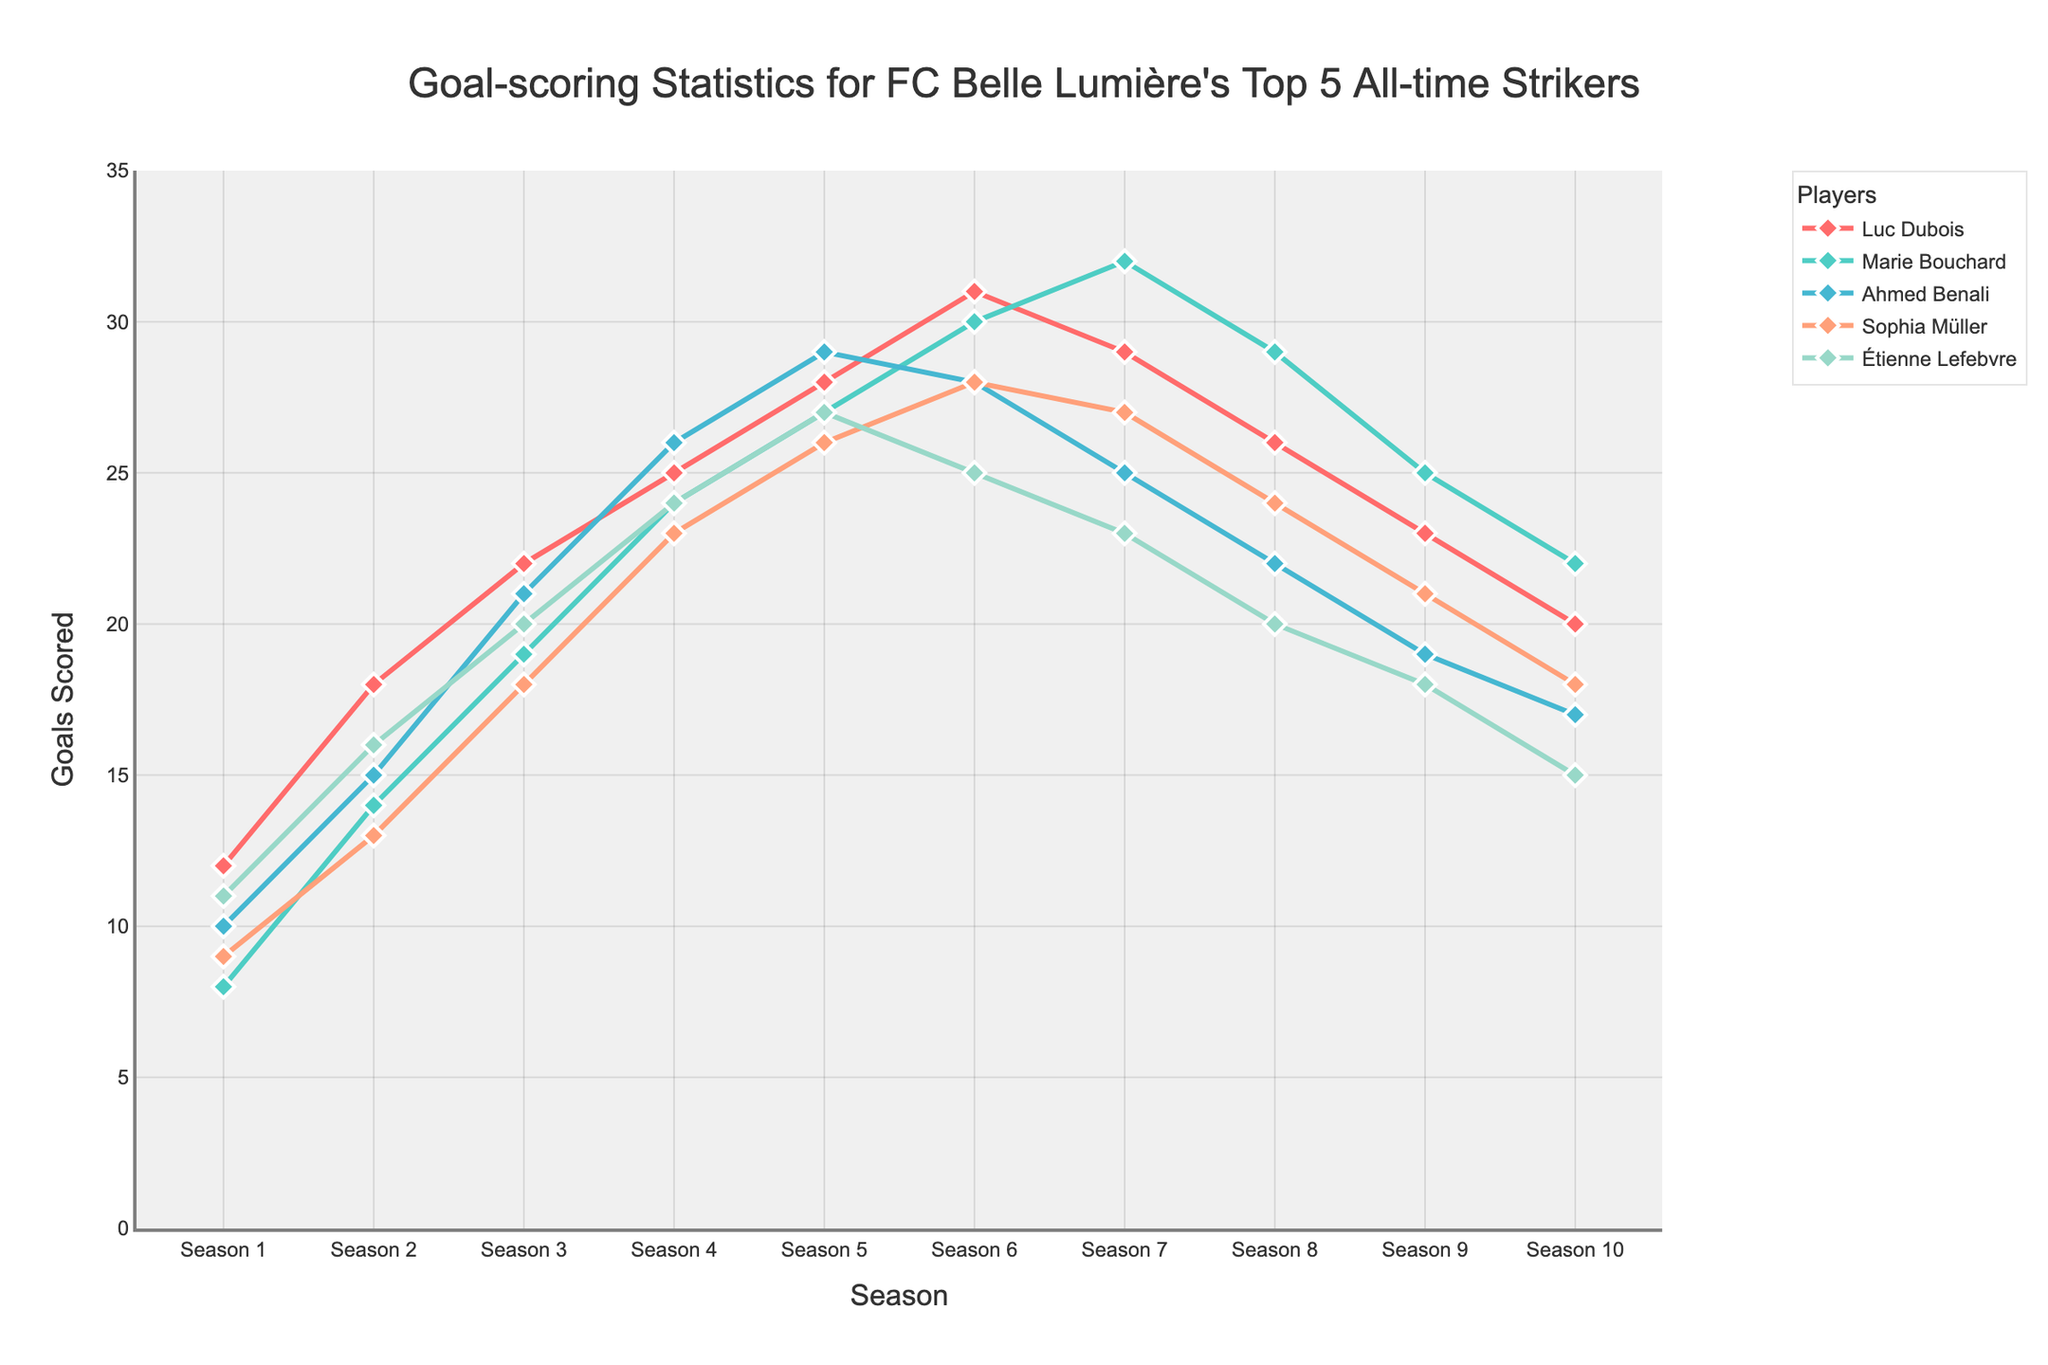What's the total number of goals scored by Luc Dubois after Season 5? After Season 5, Luc Dubois scored: 28 (Season 5) + 31 (Season 6) + 29 (Season 7) + 26 (Season 8) + 23 (Season 9) + 20 (Season 10) = 157 goals.
Answer: 157 Which player had the highest number of goals in their career's peak season? Marie Bouchard scored the highest with 32 goals in Season 7.
Answer: Marie Bouchard Between Ahmed Benali and Sophia Müller, who had a higher goal count in Season 4? In Season 4, Ahmed Benali scored 26 goals, while Sophia Müller scored 23 goals.
Answer: Ahmed Benali Which player showed a decline in goals scored over the last 3 seasons? Examining the last 3 seasons: Luc Dubois (26, 23, 20), Ahmed Benali (22, 19, 17), Sophia Müller (24, 21, 18), Étienne Lefebvre (20, 18, 15), all show a decline, but Marie Bouchard shows the smallest decline (29, 25, 22).
Answer: Ahmed Benali, Luc Dubois, Sophia Müller, Étienne Lefebvre What's the average number of goals scored by Sophia Müller over her first 5 seasons? Over her first 5 seasons, Sophia Müller scored: (9 + 13 + 18 + 23 + 26) = 89 goals. The average is 89/5 = 17.8.
Answer: 17.8 How many goals did Étienne Lefebvre score in total over his career? Summing up goals for all seasons: 11 + 16 + 20 + 24 + 27 + 25 + 23 + 20 + 18 + 15 = 199 goals.
Answer: 199 Who had the steepest increase in goals from Season 1 to their peak season? Marie Bouchard increased from 8 to 32 goals, an increase of 24 goals. Other players had less steep increases.
Answer: Marie Bouchard Between Seasons 5 and 7, which player had the most consistent goal-scoring pattern? Between Seasons 5 and 7, Sophia Müller had scores of 26, 28, and 27, showing the least variation.
Answer: Sophia Müller Which player's goal count showed a peak and then a decline, never fully recovering? Luc Dubois peaked at Season 6 with 31 goals then declined steadily to 20 goals by Season 10.
Answer: Luc Dubois 